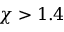<formula> <loc_0><loc_0><loc_500><loc_500>\chi > 1 . 4</formula> 